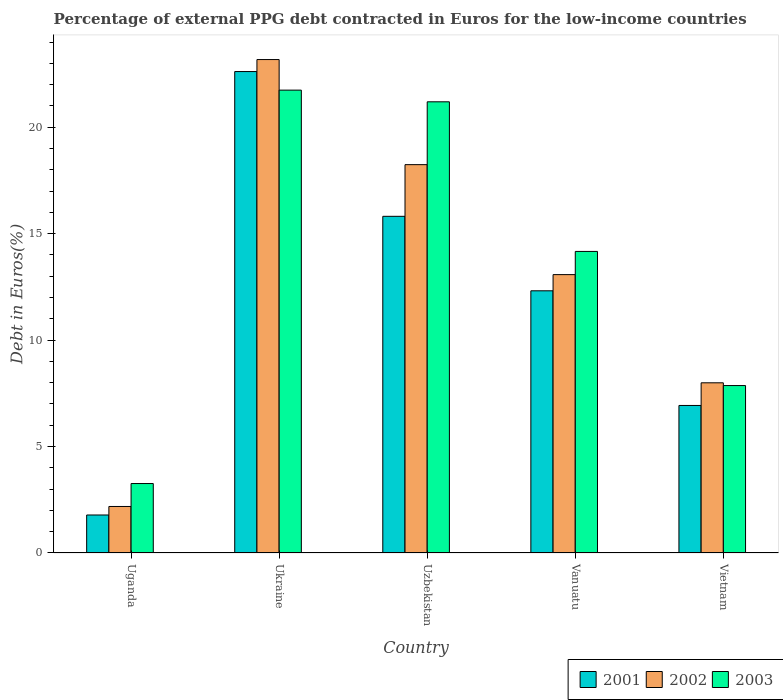How many bars are there on the 4th tick from the left?
Make the answer very short. 3. What is the label of the 2nd group of bars from the left?
Your response must be concise. Ukraine. What is the percentage of external PPG debt contracted in Euros in 2001 in Uzbekistan?
Provide a short and direct response. 15.81. Across all countries, what is the maximum percentage of external PPG debt contracted in Euros in 2002?
Your answer should be compact. 23.18. Across all countries, what is the minimum percentage of external PPG debt contracted in Euros in 2001?
Make the answer very short. 1.79. In which country was the percentage of external PPG debt contracted in Euros in 2002 maximum?
Make the answer very short. Ukraine. In which country was the percentage of external PPG debt contracted in Euros in 2003 minimum?
Provide a short and direct response. Uganda. What is the total percentage of external PPG debt contracted in Euros in 2001 in the graph?
Offer a very short reply. 59.46. What is the difference between the percentage of external PPG debt contracted in Euros in 2003 in Uganda and that in Vanuatu?
Provide a succinct answer. -10.9. What is the difference between the percentage of external PPG debt contracted in Euros in 2002 in Uzbekistan and the percentage of external PPG debt contracted in Euros in 2001 in Vietnam?
Make the answer very short. 11.31. What is the average percentage of external PPG debt contracted in Euros in 2003 per country?
Offer a terse response. 13.65. What is the difference between the percentage of external PPG debt contracted in Euros of/in 2003 and percentage of external PPG debt contracted in Euros of/in 2001 in Uzbekistan?
Make the answer very short. 5.38. What is the ratio of the percentage of external PPG debt contracted in Euros in 2002 in Vanuatu to that in Vietnam?
Provide a succinct answer. 1.64. Is the percentage of external PPG debt contracted in Euros in 2003 in Uzbekistan less than that in Vietnam?
Ensure brevity in your answer.  No. What is the difference between the highest and the second highest percentage of external PPG debt contracted in Euros in 2001?
Provide a succinct answer. -10.3. What is the difference between the highest and the lowest percentage of external PPG debt contracted in Euros in 2002?
Offer a terse response. 20.99. What does the 3rd bar from the left in Vanuatu represents?
Provide a succinct answer. 2003. Is it the case that in every country, the sum of the percentage of external PPG debt contracted in Euros in 2001 and percentage of external PPG debt contracted in Euros in 2002 is greater than the percentage of external PPG debt contracted in Euros in 2003?
Ensure brevity in your answer.  Yes. How many countries are there in the graph?
Give a very brief answer. 5. Does the graph contain any zero values?
Give a very brief answer. No. Does the graph contain grids?
Provide a succinct answer. No. How many legend labels are there?
Provide a short and direct response. 3. How are the legend labels stacked?
Ensure brevity in your answer.  Horizontal. What is the title of the graph?
Give a very brief answer. Percentage of external PPG debt contracted in Euros for the low-income countries. What is the label or title of the X-axis?
Offer a terse response. Country. What is the label or title of the Y-axis?
Make the answer very short. Debt in Euros(%). What is the Debt in Euros(%) in 2001 in Uganda?
Provide a short and direct response. 1.79. What is the Debt in Euros(%) of 2002 in Uganda?
Make the answer very short. 2.18. What is the Debt in Euros(%) in 2003 in Uganda?
Your answer should be compact. 3.26. What is the Debt in Euros(%) in 2001 in Ukraine?
Keep it short and to the point. 22.61. What is the Debt in Euros(%) in 2002 in Ukraine?
Keep it short and to the point. 23.18. What is the Debt in Euros(%) of 2003 in Ukraine?
Your answer should be compact. 21.74. What is the Debt in Euros(%) in 2001 in Uzbekistan?
Your answer should be very brief. 15.81. What is the Debt in Euros(%) of 2002 in Uzbekistan?
Your response must be concise. 18.24. What is the Debt in Euros(%) of 2003 in Uzbekistan?
Your answer should be compact. 21.19. What is the Debt in Euros(%) of 2001 in Vanuatu?
Offer a terse response. 12.32. What is the Debt in Euros(%) in 2002 in Vanuatu?
Make the answer very short. 13.08. What is the Debt in Euros(%) of 2003 in Vanuatu?
Give a very brief answer. 14.17. What is the Debt in Euros(%) of 2001 in Vietnam?
Offer a terse response. 6.93. What is the Debt in Euros(%) in 2002 in Vietnam?
Your answer should be compact. 7.99. What is the Debt in Euros(%) in 2003 in Vietnam?
Offer a terse response. 7.87. Across all countries, what is the maximum Debt in Euros(%) in 2001?
Provide a succinct answer. 22.61. Across all countries, what is the maximum Debt in Euros(%) of 2002?
Keep it short and to the point. 23.18. Across all countries, what is the maximum Debt in Euros(%) in 2003?
Keep it short and to the point. 21.74. Across all countries, what is the minimum Debt in Euros(%) in 2001?
Ensure brevity in your answer.  1.79. Across all countries, what is the minimum Debt in Euros(%) of 2002?
Offer a very short reply. 2.18. Across all countries, what is the minimum Debt in Euros(%) in 2003?
Provide a short and direct response. 3.26. What is the total Debt in Euros(%) in 2001 in the graph?
Keep it short and to the point. 59.46. What is the total Debt in Euros(%) of 2002 in the graph?
Give a very brief answer. 64.67. What is the total Debt in Euros(%) in 2003 in the graph?
Keep it short and to the point. 68.23. What is the difference between the Debt in Euros(%) in 2001 in Uganda and that in Ukraine?
Keep it short and to the point. -20.83. What is the difference between the Debt in Euros(%) of 2002 in Uganda and that in Ukraine?
Make the answer very short. -20.99. What is the difference between the Debt in Euros(%) of 2003 in Uganda and that in Ukraine?
Keep it short and to the point. -18.48. What is the difference between the Debt in Euros(%) of 2001 in Uganda and that in Uzbekistan?
Provide a short and direct response. -14.03. What is the difference between the Debt in Euros(%) of 2002 in Uganda and that in Uzbekistan?
Provide a short and direct response. -16.06. What is the difference between the Debt in Euros(%) in 2003 in Uganda and that in Uzbekistan?
Your answer should be compact. -17.93. What is the difference between the Debt in Euros(%) in 2001 in Uganda and that in Vanuatu?
Ensure brevity in your answer.  -10.53. What is the difference between the Debt in Euros(%) of 2002 in Uganda and that in Vanuatu?
Provide a succinct answer. -10.89. What is the difference between the Debt in Euros(%) of 2003 in Uganda and that in Vanuatu?
Provide a short and direct response. -10.9. What is the difference between the Debt in Euros(%) in 2001 in Uganda and that in Vietnam?
Keep it short and to the point. -5.15. What is the difference between the Debt in Euros(%) of 2002 in Uganda and that in Vietnam?
Your answer should be very brief. -5.81. What is the difference between the Debt in Euros(%) in 2003 in Uganda and that in Vietnam?
Provide a succinct answer. -4.6. What is the difference between the Debt in Euros(%) in 2001 in Ukraine and that in Uzbekistan?
Provide a short and direct response. 6.8. What is the difference between the Debt in Euros(%) of 2002 in Ukraine and that in Uzbekistan?
Your answer should be very brief. 4.94. What is the difference between the Debt in Euros(%) of 2003 in Ukraine and that in Uzbekistan?
Provide a short and direct response. 0.55. What is the difference between the Debt in Euros(%) in 2001 in Ukraine and that in Vanuatu?
Make the answer very short. 10.3. What is the difference between the Debt in Euros(%) of 2002 in Ukraine and that in Vanuatu?
Provide a short and direct response. 10.1. What is the difference between the Debt in Euros(%) in 2003 in Ukraine and that in Vanuatu?
Offer a terse response. 7.58. What is the difference between the Debt in Euros(%) of 2001 in Ukraine and that in Vietnam?
Your answer should be very brief. 15.68. What is the difference between the Debt in Euros(%) of 2002 in Ukraine and that in Vietnam?
Offer a terse response. 15.18. What is the difference between the Debt in Euros(%) in 2003 in Ukraine and that in Vietnam?
Offer a terse response. 13.88. What is the difference between the Debt in Euros(%) in 2001 in Uzbekistan and that in Vanuatu?
Ensure brevity in your answer.  3.5. What is the difference between the Debt in Euros(%) of 2002 in Uzbekistan and that in Vanuatu?
Make the answer very short. 5.17. What is the difference between the Debt in Euros(%) in 2003 in Uzbekistan and that in Vanuatu?
Provide a short and direct response. 7.03. What is the difference between the Debt in Euros(%) of 2001 in Uzbekistan and that in Vietnam?
Give a very brief answer. 8.88. What is the difference between the Debt in Euros(%) of 2002 in Uzbekistan and that in Vietnam?
Your answer should be compact. 10.25. What is the difference between the Debt in Euros(%) of 2003 in Uzbekistan and that in Vietnam?
Make the answer very short. 13.33. What is the difference between the Debt in Euros(%) in 2001 in Vanuatu and that in Vietnam?
Keep it short and to the point. 5.39. What is the difference between the Debt in Euros(%) in 2002 in Vanuatu and that in Vietnam?
Keep it short and to the point. 5.08. What is the difference between the Debt in Euros(%) in 2003 in Vanuatu and that in Vietnam?
Make the answer very short. 6.3. What is the difference between the Debt in Euros(%) in 2001 in Uganda and the Debt in Euros(%) in 2002 in Ukraine?
Your response must be concise. -21.39. What is the difference between the Debt in Euros(%) in 2001 in Uganda and the Debt in Euros(%) in 2003 in Ukraine?
Ensure brevity in your answer.  -19.96. What is the difference between the Debt in Euros(%) of 2002 in Uganda and the Debt in Euros(%) of 2003 in Ukraine?
Provide a succinct answer. -19.56. What is the difference between the Debt in Euros(%) of 2001 in Uganda and the Debt in Euros(%) of 2002 in Uzbekistan?
Offer a terse response. -16.46. What is the difference between the Debt in Euros(%) of 2001 in Uganda and the Debt in Euros(%) of 2003 in Uzbekistan?
Your answer should be compact. -19.41. What is the difference between the Debt in Euros(%) of 2002 in Uganda and the Debt in Euros(%) of 2003 in Uzbekistan?
Provide a succinct answer. -19.01. What is the difference between the Debt in Euros(%) of 2001 in Uganda and the Debt in Euros(%) of 2002 in Vanuatu?
Your answer should be compact. -11.29. What is the difference between the Debt in Euros(%) in 2001 in Uganda and the Debt in Euros(%) in 2003 in Vanuatu?
Give a very brief answer. -12.38. What is the difference between the Debt in Euros(%) of 2002 in Uganda and the Debt in Euros(%) of 2003 in Vanuatu?
Offer a terse response. -11.98. What is the difference between the Debt in Euros(%) of 2001 in Uganda and the Debt in Euros(%) of 2002 in Vietnam?
Offer a terse response. -6.21. What is the difference between the Debt in Euros(%) in 2001 in Uganda and the Debt in Euros(%) in 2003 in Vietnam?
Offer a terse response. -6.08. What is the difference between the Debt in Euros(%) in 2002 in Uganda and the Debt in Euros(%) in 2003 in Vietnam?
Your answer should be compact. -5.68. What is the difference between the Debt in Euros(%) in 2001 in Ukraine and the Debt in Euros(%) in 2002 in Uzbekistan?
Give a very brief answer. 4.37. What is the difference between the Debt in Euros(%) in 2001 in Ukraine and the Debt in Euros(%) in 2003 in Uzbekistan?
Ensure brevity in your answer.  1.42. What is the difference between the Debt in Euros(%) of 2002 in Ukraine and the Debt in Euros(%) of 2003 in Uzbekistan?
Keep it short and to the point. 1.99. What is the difference between the Debt in Euros(%) in 2001 in Ukraine and the Debt in Euros(%) in 2002 in Vanuatu?
Make the answer very short. 9.54. What is the difference between the Debt in Euros(%) in 2001 in Ukraine and the Debt in Euros(%) in 2003 in Vanuatu?
Offer a very short reply. 8.45. What is the difference between the Debt in Euros(%) in 2002 in Ukraine and the Debt in Euros(%) in 2003 in Vanuatu?
Ensure brevity in your answer.  9.01. What is the difference between the Debt in Euros(%) in 2001 in Ukraine and the Debt in Euros(%) in 2002 in Vietnam?
Keep it short and to the point. 14.62. What is the difference between the Debt in Euros(%) of 2001 in Ukraine and the Debt in Euros(%) of 2003 in Vietnam?
Provide a short and direct response. 14.75. What is the difference between the Debt in Euros(%) of 2002 in Ukraine and the Debt in Euros(%) of 2003 in Vietnam?
Ensure brevity in your answer.  15.31. What is the difference between the Debt in Euros(%) in 2001 in Uzbekistan and the Debt in Euros(%) in 2002 in Vanuatu?
Offer a terse response. 2.74. What is the difference between the Debt in Euros(%) in 2001 in Uzbekistan and the Debt in Euros(%) in 2003 in Vanuatu?
Make the answer very short. 1.65. What is the difference between the Debt in Euros(%) of 2002 in Uzbekistan and the Debt in Euros(%) of 2003 in Vanuatu?
Offer a very short reply. 4.08. What is the difference between the Debt in Euros(%) of 2001 in Uzbekistan and the Debt in Euros(%) of 2002 in Vietnam?
Your response must be concise. 7.82. What is the difference between the Debt in Euros(%) in 2001 in Uzbekistan and the Debt in Euros(%) in 2003 in Vietnam?
Your answer should be very brief. 7.95. What is the difference between the Debt in Euros(%) of 2002 in Uzbekistan and the Debt in Euros(%) of 2003 in Vietnam?
Give a very brief answer. 10.38. What is the difference between the Debt in Euros(%) of 2001 in Vanuatu and the Debt in Euros(%) of 2002 in Vietnam?
Provide a short and direct response. 4.32. What is the difference between the Debt in Euros(%) in 2001 in Vanuatu and the Debt in Euros(%) in 2003 in Vietnam?
Your answer should be very brief. 4.45. What is the difference between the Debt in Euros(%) in 2002 in Vanuatu and the Debt in Euros(%) in 2003 in Vietnam?
Keep it short and to the point. 5.21. What is the average Debt in Euros(%) of 2001 per country?
Provide a short and direct response. 11.89. What is the average Debt in Euros(%) of 2002 per country?
Keep it short and to the point. 12.94. What is the average Debt in Euros(%) of 2003 per country?
Offer a terse response. 13.65. What is the difference between the Debt in Euros(%) in 2001 and Debt in Euros(%) in 2002 in Uganda?
Keep it short and to the point. -0.4. What is the difference between the Debt in Euros(%) of 2001 and Debt in Euros(%) of 2003 in Uganda?
Offer a terse response. -1.48. What is the difference between the Debt in Euros(%) of 2002 and Debt in Euros(%) of 2003 in Uganda?
Offer a terse response. -1.08. What is the difference between the Debt in Euros(%) of 2001 and Debt in Euros(%) of 2002 in Ukraine?
Give a very brief answer. -0.56. What is the difference between the Debt in Euros(%) in 2001 and Debt in Euros(%) in 2003 in Ukraine?
Keep it short and to the point. 0.87. What is the difference between the Debt in Euros(%) of 2002 and Debt in Euros(%) of 2003 in Ukraine?
Make the answer very short. 1.44. What is the difference between the Debt in Euros(%) in 2001 and Debt in Euros(%) in 2002 in Uzbekistan?
Keep it short and to the point. -2.43. What is the difference between the Debt in Euros(%) of 2001 and Debt in Euros(%) of 2003 in Uzbekistan?
Ensure brevity in your answer.  -5.38. What is the difference between the Debt in Euros(%) in 2002 and Debt in Euros(%) in 2003 in Uzbekistan?
Ensure brevity in your answer.  -2.95. What is the difference between the Debt in Euros(%) in 2001 and Debt in Euros(%) in 2002 in Vanuatu?
Your response must be concise. -0.76. What is the difference between the Debt in Euros(%) in 2001 and Debt in Euros(%) in 2003 in Vanuatu?
Provide a succinct answer. -1.85. What is the difference between the Debt in Euros(%) in 2002 and Debt in Euros(%) in 2003 in Vanuatu?
Offer a very short reply. -1.09. What is the difference between the Debt in Euros(%) in 2001 and Debt in Euros(%) in 2002 in Vietnam?
Provide a short and direct response. -1.06. What is the difference between the Debt in Euros(%) in 2001 and Debt in Euros(%) in 2003 in Vietnam?
Ensure brevity in your answer.  -0.94. What is the difference between the Debt in Euros(%) in 2002 and Debt in Euros(%) in 2003 in Vietnam?
Provide a succinct answer. 0.13. What is the ratio of the Debt in Euros(%) of 2001 in Uganda to that in Ukraine?
Offer a very short reply. 0.08. What is the ratio of the Debt in Euros(%) in 2002 in Uganda to that in Ukraine?
Provide a succinct answer. 0.09. What is the ratio of the Debt in Euros(%) in 2003 in Uganda to that in Ukraine?
Your response must be concise. 0.15. What is the ratio of the Debt in Euros(%) of 2001 in Uganda to that in Uzbekistan?
Ensure brevity in your answer.  0.11. What is the ratio of the Debt in Euros(%) in 2002 in Uganda to that in Uzbekistan?
Provide a succinct answer. 0.12. What is the ratio of the Debt in Euros(%) of 2003 in Uganda to that in Uzbekistan?
Offer a very short reply. 0.15. What is the ratio of the Debt in Euros(%) in 2001 in Uganda to that in Vanuatu?
Ensure brevity in your answer.  0.14. What is the ratio of the Debt in Euros(%) in 2002 in Uganda to that in Vanuatu?
Provide a succinct answer. 0.17. What is the ratio of the Debt in Euros(%) in 2003 in Uganda to that in Vanuatu?
Provide a short and direct response. 0.23. What is the ratio of the Debt in Euros(%) of 2001 in Uganda to that in Vietnam?
Offer a terse response. 0.26. What is the ratio of the Debt in Euros(%) of 2002 in Uganda to that in Vietnam?
Offer a terse response. 0.27. What is the ratio of the Debt in Euros(%) in 2003 in Uganda to that in Vietnam?
Your answer should be compact. 0.41. What is the ratio of the Debt in Euros(%) of 2001 in Ukraine to that in Uzbekistan?
Keep it short and to the point. 1.43. What is the ratio of the Debt in Euros(%) in 2002 in Ukraine to that in Uzbekistan?
Give a very brief answer. 1.27. What is the ratio of the Debt in Euros(%) of 2003 in Ukraine to that in Uzbekistan?
Your answer should be very brief. 1.03. What is the ratio of the Debt in Euros(%) of 2001 in Ukraine to that in Vanuatu?
Provide a short and direct response. 1.84. What is the ratio of the Debt in Euros(%) in 2002 in Ukraine to that in Vanuatu?
Give a very brief answer. 1.77. What is the ratio of the Debt in Euros(%) of 2003 in Ukraine to that in Vanuatu?
Offer a very short reply. 1.53. What is the ratio of the Debt in Euros(%) in 2001 in Ukraine to that in Vietnam?
Your response must be concise. 3.26. What is the ratio of the Debt in Euros(%) of 2002 in Ukraine to that in Vietnam?
Your answer should be very brief. 2.9. What is the ratio of the Debt in Euros(%) in 2003 in Ukraine to that in Vietnam?
Keep it short and to the point. 2.76. What is the ratio of the Debt in Euros(%) in 2001 in Uzbekistan to that in Vanuatu?
Your response must be concise. 1.28. What is the ratio of the Debt in Euros(%) of 2002 in Uzbekistan to that in Vanuatu?
Your answer should be compact. 1.4. What is the ratio of the Debt in Euros(%) of 2003 in Uzbekistan to that in Vanuatu?
Provide a short and direct response. 1.5. What is the ratio of the Debt in Euros(%) of 2001 in Uzbekistan to that in Vietnam?
Make the answer very short. 2.28. What is the ratio of the Debt in Euros(%) of 2002 in Uzbekistan to that in Vietnam?
Give a very brief answer. 2.28. What is the ratio of the Debt in Euros(%) of 2003 in Uzbekistan to that in Vietnam?
Provide a short and direct response. 2.69. What is the ratio of the Debt in Euros(%) of 2001 in Vanuatu to that in Vietnam?
Your answer should be compact. 1.78. What is the ratio of the Debt in Euros(%) in 2002 in Vanuatu to that in Vietnam?
Give a very brief answer. 1.64. What is the ratio of the Debt in Euros(%) in 2003 in Vanuatu to that in Vietnam?
Offer a very short reply. 1.8. What is the difference between the highest and the second highest Debt in Euros(%) in 2001?
Your answer should be very brief. 6.8. What is the difference between the highest and the second highest Debt in Euros(%) of 2002?
Keep it short and to the point. 4.94. What is the difference between the highest and the second highest Debt in Euros(%) of 2003?
Your response must be concise. 0.55. What is the difference between the highest and the lowest Debt in Euros(%) in 2001?
Your answer should be very brief. 20.83. What is the difference between the highest and the lowest Debt in Euros(%) in 2002?
Your answer should be compact. 20.99. What is the difference between the highest and the lowest Debt in Euros(%) in 2003?
Keep it short and to the point. 18.48. 